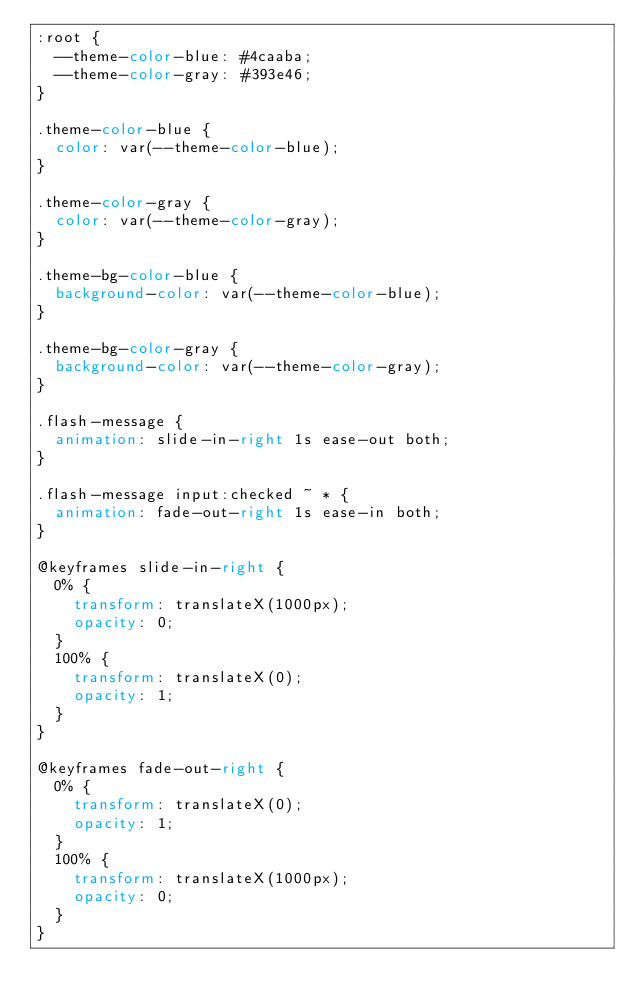Convert code to text. <code><loc_0><loc_0><loc_500><loc_500><_CSS_>:root {
  --theme-color-blue: #4caaba;
  --theme-color-gray: #393e46;
}

.theme-color-blue {
  color: var(--theme-color-blue);
}

.theme-color-gray {
  color: var(--theme-color-gray);
}

.theme-bg-color-blue {
  background-color: var(--theme-color-blue);
}

.theme-bg-color-gray {
  background-color: var(--theme-color-gray);
}

.flash-message {
  animation: slide-in-right 1s ease-out both;
}

.flash-message input:checked ~ * {
  animation: fade-out-right 1s ease-in both;
}

@keyframes slide-in-right {
  0% {
    transform: translateX(1000px);
    opacity: 0;
  }
  100% {
    transform: translateX(0);
    opacity: 1;
  }
}

@keyframes fade-out-right {
  0% {
    transform: translateX(0);
    opacity: 1;
  }
  100% {
    transform: translateX(1000px);
    opacity: 0;
  }
}
</code> 